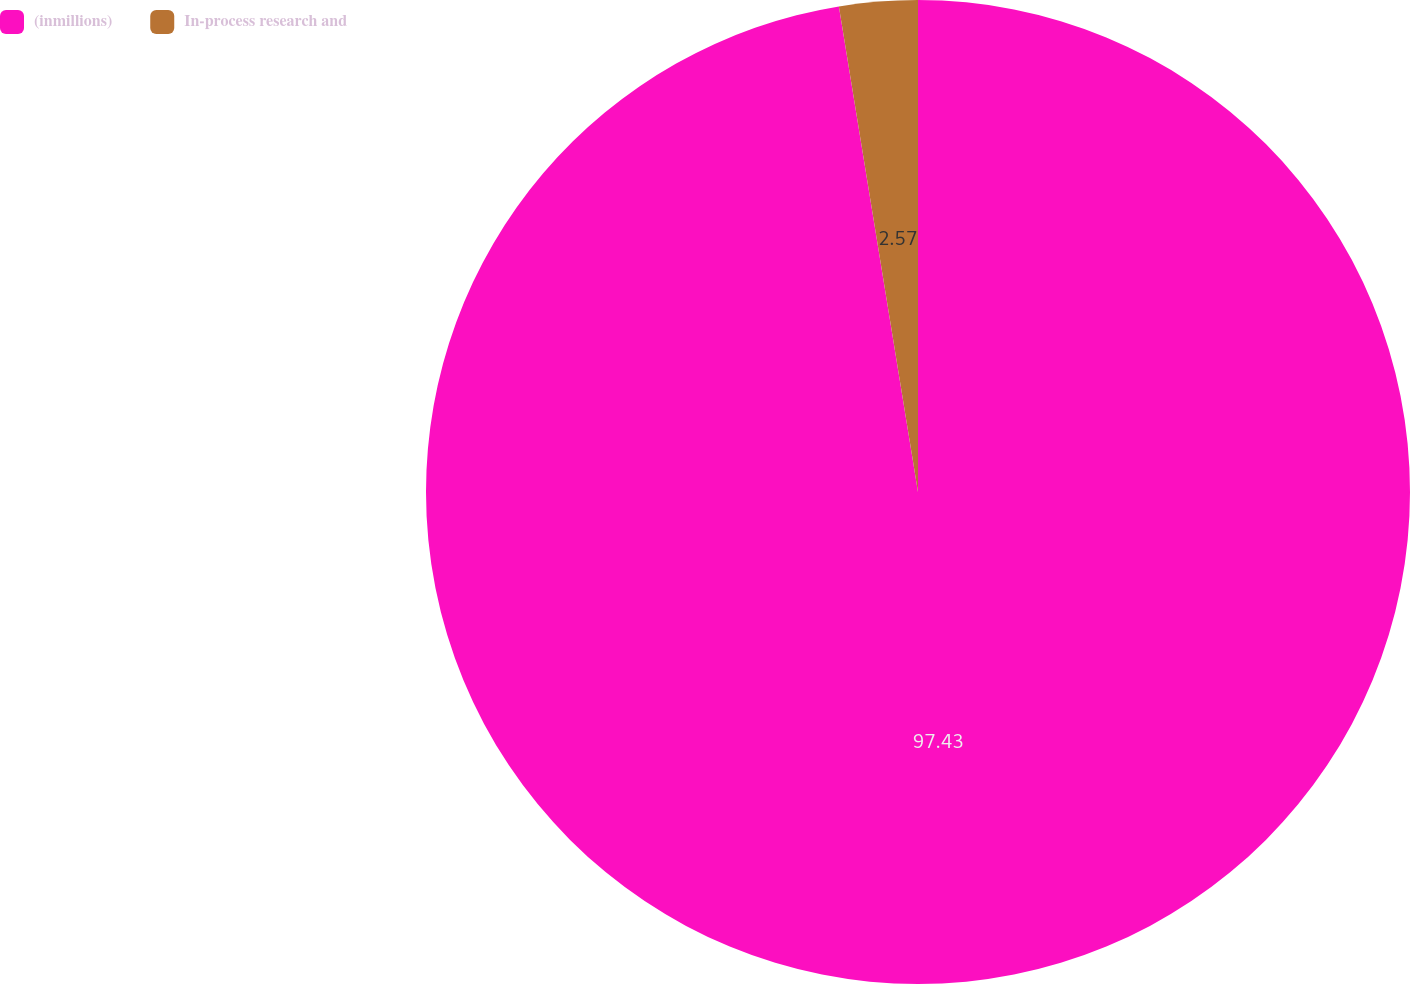Convert chart. <chart><loc_0><loc_0><loc_500><loc_500><pie_chart><fcel>(inmillions)<fcel>In-process research and<nl><fcel>97.43%<fcel>2.57%<nl></chart> 